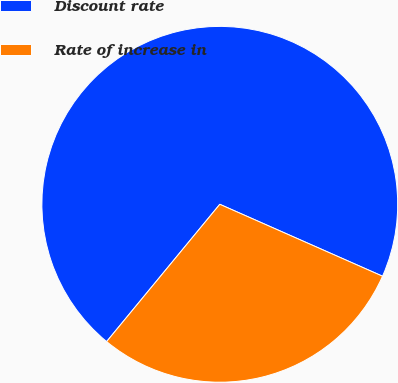<chart> <loc_0><loc_0><loc_500><loc_500><pie_chart><fcel>Discount rate<fcel>Rate of increase in<nl><fcel>70.65%<fcel>29.35%<nl></chart> 